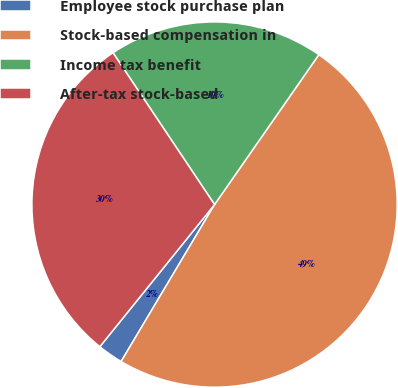<chart> <loc_0><loc_0><loc_500><loc_500><pie_chart><fcel>Employee stock purchase plan<fcel>Stock-based compensation in<fcel>Income tax benefit<fcel>After-tax stock-based<nl><fcel>2.26%<fcel>48.87%<fcel>19.06%<fcel>29.81%<nl></chart> 